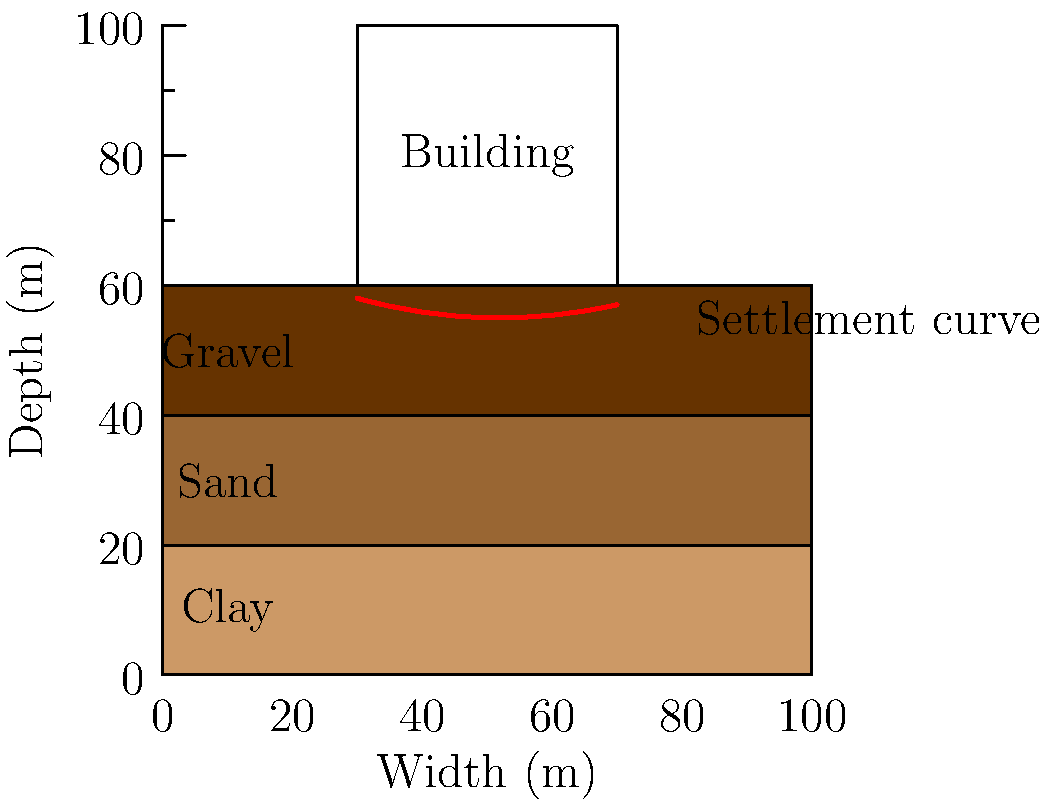In the context of IT integration for multinational construction projects, consider a building foundation resting on layered soil as shown in the diagram. The settlement curve indicates non-uniform settlement. What factor is most likely contributing to this pattern, and how might digital modeling tools assist in predicting and mitigating such issues? To answer this question, we need to consider several factors:

1. Soil composition: The diagram shows three distinct soil layers - clay, sand, and gravel.

2. Settlement pattern: The settlement curve is non-uniform, with more settlement in the center than at the edges.

3. IT integration in construction: Digital modeling tools can significantly aid in predicting and mitigating soil settlement issues.

Step-by-step analysis:

1. Clay layer at the bottom: Clay is known for its high compressibility and potential for consolidation settlement.

2. Non-uniform settlement: The greater settlement in the center suggests that the load distribution or soil properties are not uniform across the foundation width.

3. Most likely factor: The varying thickness of the clay layer beneath the foundation is the most probable cause of the observed settlement pattern. The clay layer appears thicker in the center, leading to more settlement in that area.

4. Digital modeling tools: Advanced geotechnical software can help in:
   a) Creating 3D soil models based on borehole data and geophysical surveys.
   b) Simulating load distribution and resulting settlements using Finite Element Analysis (FEA).
   c) Predicting long-term settlement patterns considering soil consolidation.
   d) Optimizing foundation design to minimize differential settlement.

5. Mitigation strategies: Based on digital model predictions, engineers can implement solutions such as:
   a) Soil improvement techniques (e.g., preloading, dynamic compaction)
   b) Adjusting foundation design (e.g., using piles to transfer loads to more stable layers)
   c) Structural modifications to better accommodate predicted settlements

6. IT integration benefits: Multinational corporations can leverage these digital tools to:
   a) Standardize geotechnical analysis across global projects
   b) Facilitate remote collaboration between experts in different locations
   c) Create a database of soil conditions and foundation performance for future projects
   d) Integrate settlement predictions with Building Information Modeling (BIM) for holistic project management
Answer: Varying clay layer thickness; digital modeling enables 3D soil simulation, FEA-based settlement prediction, and optimized foundation design. 